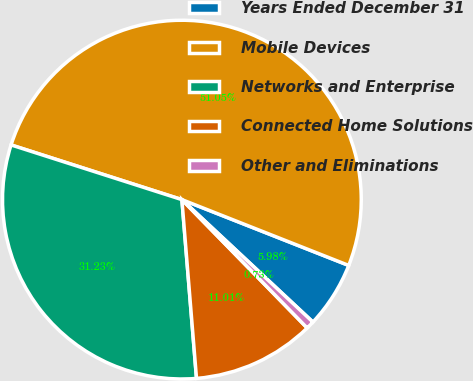Convert chart. <chart><loc_0><loc_0><loc_500><loc_500><pie_chart><fcel>Years Ended December 31<fcel>Mobile Devices<fcel>Networks and Enterprise<fcel>Connected Home Solutions<fcel>Other and Eliminations<nl><fcel>5.98%<fcel>51.05%<fcel>31.23%<fcel>11.01%<fcel>0.73%<nl></chart> 